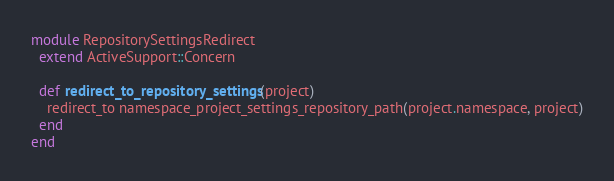Convert code to text. <code><loc_0><loc_0><loc_500><loc_500><_Ruby_>module RepositorySettingsRedirect
  extend ActiveSupport::Concern

  def redirect_to_repository_settings(project)
    redirect_to namespace_project_settings_repository_path(project.namespace, project)
  end
end
</code> 